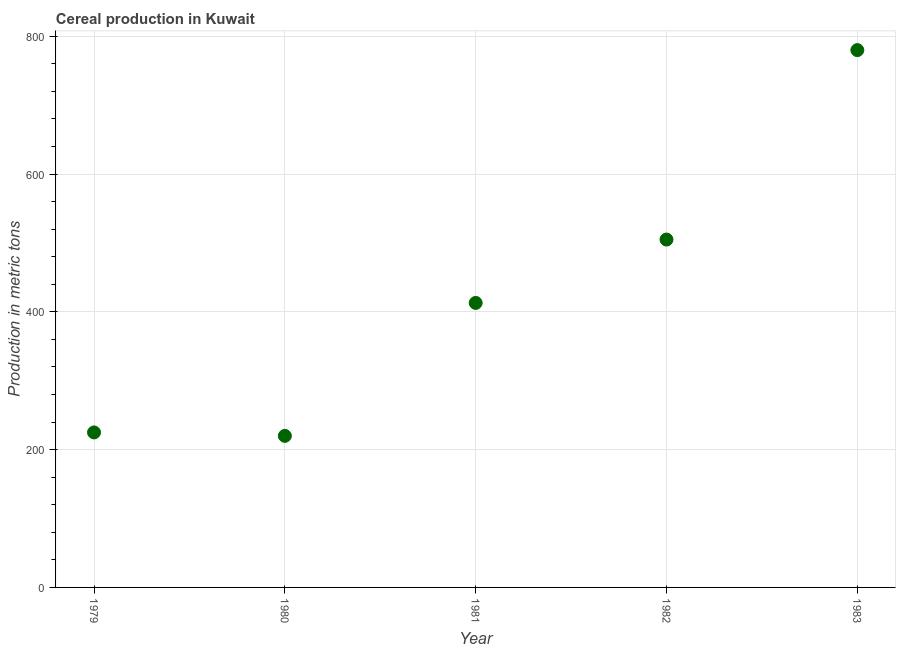What is the cereal production in 1981?
Make the answer very short. 413. Across all years, what is the maximum cereal production?
Your response must be concise. 780. Across all years, what is the minimum cereal production?
Your answer should be very brief. 220. In which year was the cereal production minimum?
Provide a short and direct response. 1980. What is the sum of the cereal production?
Ensure brevity in your answer.  2143. What is the difference between the cereal production in 1979 and 1983?
Your answer should be very brief. -555. What is the average cereal production per year?
Make the answer very short. 428.6. What is the median cereal production?
Provide a succinct answer. 413. Do a majority of the years between 1979 and 1983 (inclusive) have cereal production greater than 160 metric tons?
Your response must be concise. Yes. What is the ratio of the cereal production in 1980 to that in 1981?
Provide a succinct answer. 0.53. Is the cereal production in 1979 less than that in 1980?
Your response must be concise. No. What is the difference between the highest and the second highest cereal production?
Your answer should be very brief. 275. What is the difference between the highest and the lowest cereal production?
Make the answer very short. 560. What is the difference between two consecutive major ticks on the Y-axis?
Keep it short and to the point. 200. Does the graph contain any zero values?
Provide a succinct answer. No. Does the graph contain grids?
Provide a succinct answer. Yes. What is the title of the graph?
Your answer should be very brief. Cereal production in Kuwait. What is the label or title of the X-axis?
Your response must be concise. Year. What is the label or title of the Y-axis?
Your answer should be compact. Production in metric tons. What is the Production in metric tons in 1979?
Give a very brief answer. 225. What is the Production in metric tons in 1980?
Offer a terse response. 220. What is the Production in metric tons in 1981?
Offer a very short reply. 413. What is the Production in metric tons in 1982?
Your answer should be compact. 505. What is the Production in metric tons in 1983?
Ensure brevity in your answer.  780. What is the difference between the Production in metric tons in 1979 and 1980?
Ensure brevity in your answer.  5. What is the difference between the Production in metric tons in 1979 and 1981?
Give a very brief answer. -188. What is the difference between the Production in metric tons in 1979 and 1982?
Ensure brevity in your answer.  -280. What is the difference between the Production in metric tons in 1979 and 1983?
Your response must be concise. -555. What is the difference between the Production in metric tons in 1980 and 1981?
Give a very brief answer. -193. What is the difference between the Production in metric tons in 1980 and 1982?
Provide a succinct answer. -285. What is the difference between the Production in metric tons in 1980 and 1983?
Your response must be concise. -560. What is the difference between the Production in metric tons in 1981 and 1982?
Provide a succinct answer. -92. What is the difference between the Production in metric tons in 1981 and 1983?
Keep it short and to the point. -367. What is the difference between the Production in metric tons in 1982 and 1983?
Offer a terse response. -275. What is the ratio of the Production in metric tons in 1979 to that in 1981?
Your answer should be very brief. 0.55. What is the ratio of the Production in metric tons in 1979 to that in 1982?
Make the answer very short. 0.45. What is the ratio of the Production in metric tons in 1979 to that in 1983?
Give a very brief answer. 0.29. What is the ratio of the Production in metric tons in 1980 to that in 1981?
Your response must be concise. 0.53. What is the ratio of the Production in metric tons in 1980 to that in 1982?
Give a very brief answer. 0.44. What is the ratio of the Production in metric tons in 1980 to that in 1983?
Make the answer very short. 0.28. What is the ratio of the Production in metric tons in 1981 to that in 1982?
Ensure brevity in your answer.  0.82. What is the ratio of the Production in metric tons in 1981 to that in 1983?
Ensure brevity in your answer.  0.53. What is the ratio of the Production in metric tons in 1982 to that in 1983?
Offer a terse response. 0.65. 